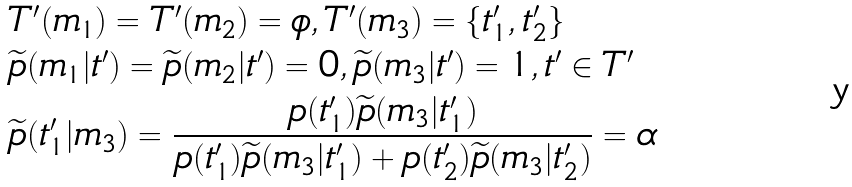<formula> <loc_0><loc_0><loc_500><loc_500>& T ^ { \prime } ( m _ { 1 } ) = T ^ { \prime } ( m _ { 2 } ) = \phi , T ^ { \prime } ( m _ { 3 } ) = \{ t ^ { \prime } _ { 1 } , t ^ { \prime } _ { 2 } \} \\ & \widetilde { p } ( m _ { 1 } | t ^ { \prime } ) = \widetilde { p } ( m _ { 2 } | t ^ { \prime } ) = 0 , \widetilde { p } ( m _ { 3 } | t ^ { \prime } ) = 1 , t ^ { \prime } \in T ^ { \prime } \\ & \widetilde { p } ( t ^ { \prime } _ { 1 } | m _ { 3 } ) = \frac { p ( t ^ { \prime } _ { 1 } ) \widetilde { p } ( m _ { 3 } | t ^ { \prime } _ { 1 } ) } { p ( t ^ { \prime } _ { 1 } ) \widetilde { p } ( m _ { 3 } | t ^ { \prime } _ { 1 } ) + p ( t ^ { \prime } _ { 2 } ) \widetilde { p } ( m _ { 3 } | t ^ { \prime } _ { 2 } ) } = \alpha</formula> 